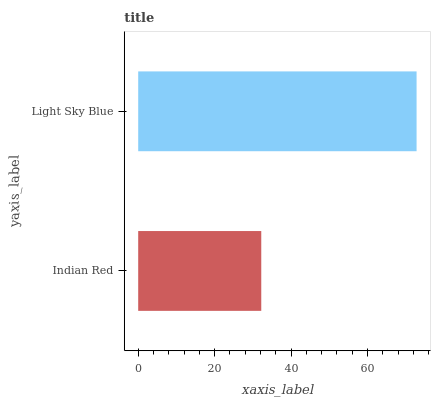Is Indian Red the minimum?
Answer yes or no. Yes. Is Light Sky Blue the maximum?
Answer yes or no. Yes. Is Light Sky Blue the minimum?
Answer yes or no. No. Is Light Sky Blue greater than Indian Red?
Answer yes or no. Yes. Is Indian Red less than Light Sky Blue?
Answer yes or no. Yes. Is Indian Red greater than Light Sky Blue?
Answer yes or no. No. Is Light Sky Blue less than Indian Red?
Answer yes or no. No. Is Light Sky Blue the high median?
Answer yes or no. Yes. Is Indian Red the low median?
Answer yes or no. Yes. Is Indian Red the high median?
Answer yes or no. No. Is Light Sky Blue the low median?
Answer yes or no. No. 